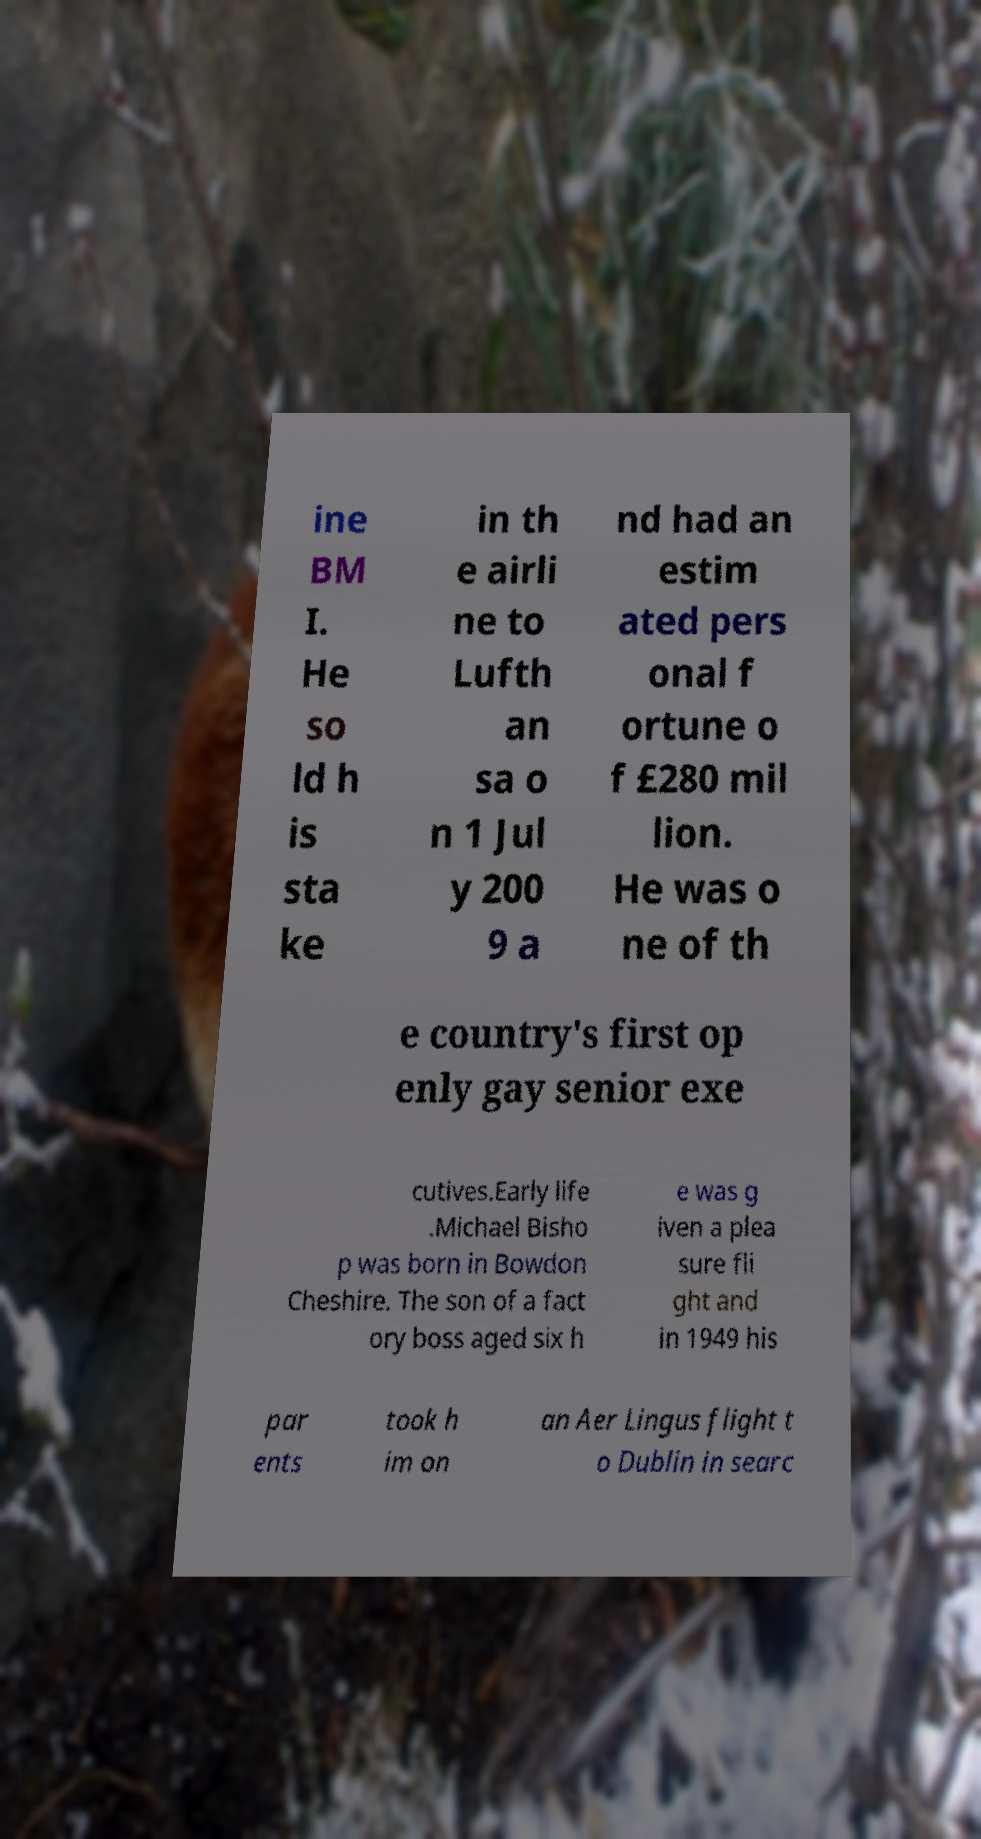There's text embedded in this image that I need extracted. Can you transcribe it verbatim? ine BM I. He so ld h is sta ke in th e airli ne to Lufth an sa o n 1 Jul y 200 9 a nd had an estim ated pers onal f ortune o f £280 mil lion. He was o ne of th e country's first op enly gay senior exe cutives.Early life .Michael Bisho p was born in Bowdon Cheshire. The son of a fact ory boss aged six h e was g iven a plea sure fli ght and in 1949 his par ents took h im on an Aer Lingus flight t o Dublin in searc 